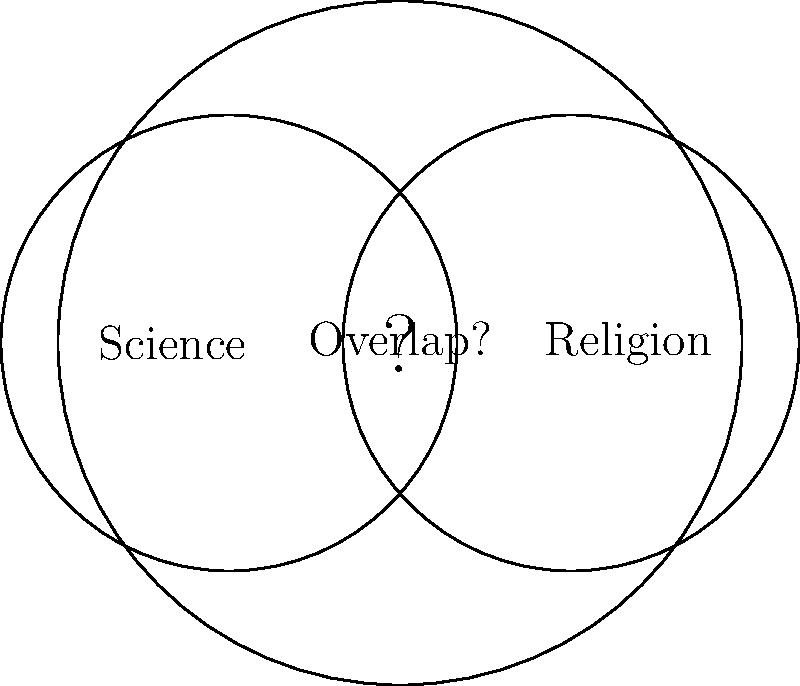In the diagram above, two circles represent the domains of scientific and religious knowledge within a larger circle of all knowledge. What does the area where the two circles overlap suggest about the relationship between science and religion according to the non-overlapping magisteria (NOMA) principle? To answer this question, let's consider the following steps:

1. Understand the NOMA principle: The Non-Overlapping Magisteria (NOMA) principle, proposed by Stephen Jay Gould, suggests that science and religion occupy separate domains of knowledge.

2. Analyze the diagram:
   a. The large outer circle represents all knowledge.
   b. The left circle represents scientific knowledge.
   c. The right circle represents religious knowledge.
   d. There is an overlapping area between the two circles with a question mark.

3. Consider the implications of NOMA:
   a. According to NOMA, science and religion should not overlap in their domains.
   b. Science deals with empirical facts and theories about the natural world.
   c. Religion deals with questions of ultimate meaning, moral values, and purpose.

4. Interpret the overlapping area:
   a. The presence of an overlap with a question mark suggests a potential conflict or interaction between science and religion.
   b. However, NOMA argues that this overlap should not exist or is illusory.

5. Conclude based on NOMA:
   The overlapping area in the diagram contradicts the NOMA principle, which asserts that science and religion operate in distinct, non-overlapping domains of knowledge.
Answer: The overlap contradicts NOMA. 